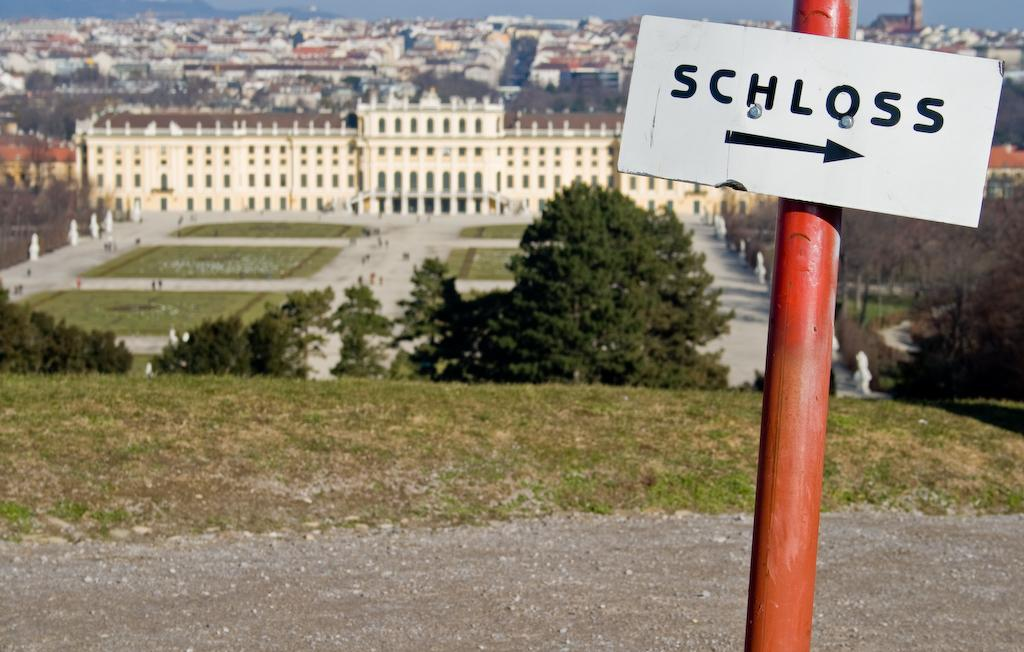<image>
Share a concise interpretation of the image provided. A sign on a red post labelled SCHLOSS 